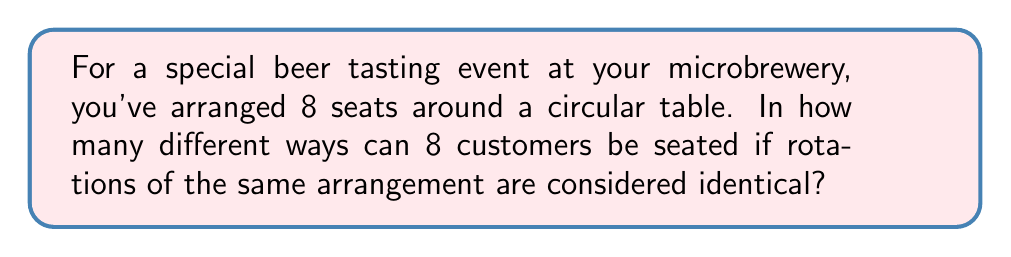Teach me how to tackle this problem. Let's approach this step-by-step:

1) First, we need to recognize that this is a circular permutation problem. In a circular arrangement, rotations of the same arrangement are considered identical.

2) For a linear arrangement of 8 people, we would have 8! (8 factorial) possibilities.

3) However, in a circular arrangement, we can fix one person's position and arrange the rest. This is because rotating everyone one seat to the right (or left) would produce an arrangement we consider identical.

4) Therefore, we can think of this as arranging the remaining 7 people in a line, which gives us 7! possibilities.

5) The formula for circular permutations of $n$ distinct objects is:

   $$(n-1)!$$

6) In this case, $n = 8$, so we have:

   $$(8-1)! = 7!$$

7) Calculating 7!:

   $$7! = 7 \times 6 \times 5 \times 4 \times 3 \times 2 \times 1 = 5040$$

Thus, there are 5040 different ways to seat 8 customers around the circular table for the beer tasting event.
Answer: 5040 